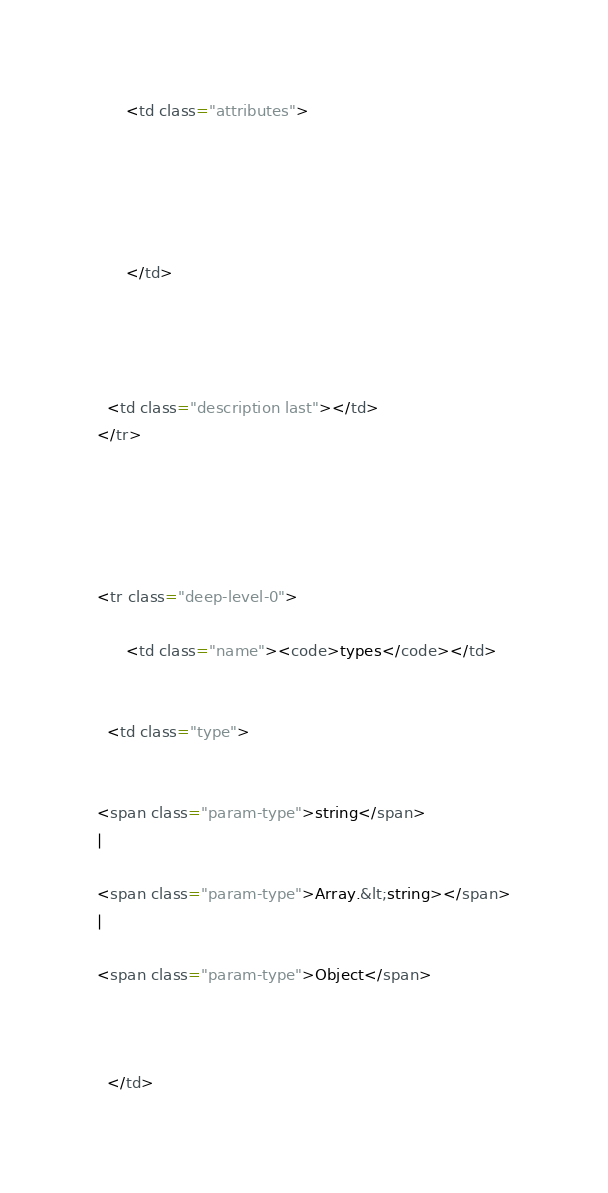Convert code to text. <code><loc_0><loc_0><loc_500><loc_500><_HTML_>      <td class="attributes">
      

      

      
      </td>
  

  

  <td class="description last"></td>
</tr>


        

            
<tr class="deep-level-0">
  
      <td class="name"><code>types</code></td>
  

  <td class="type">
  
      
<span class="param-type">string</span>
|

<span class="param-type">Array.&lt;string></span>
|

<span class="param-type">Object</span>


  
  </td>
</code> 